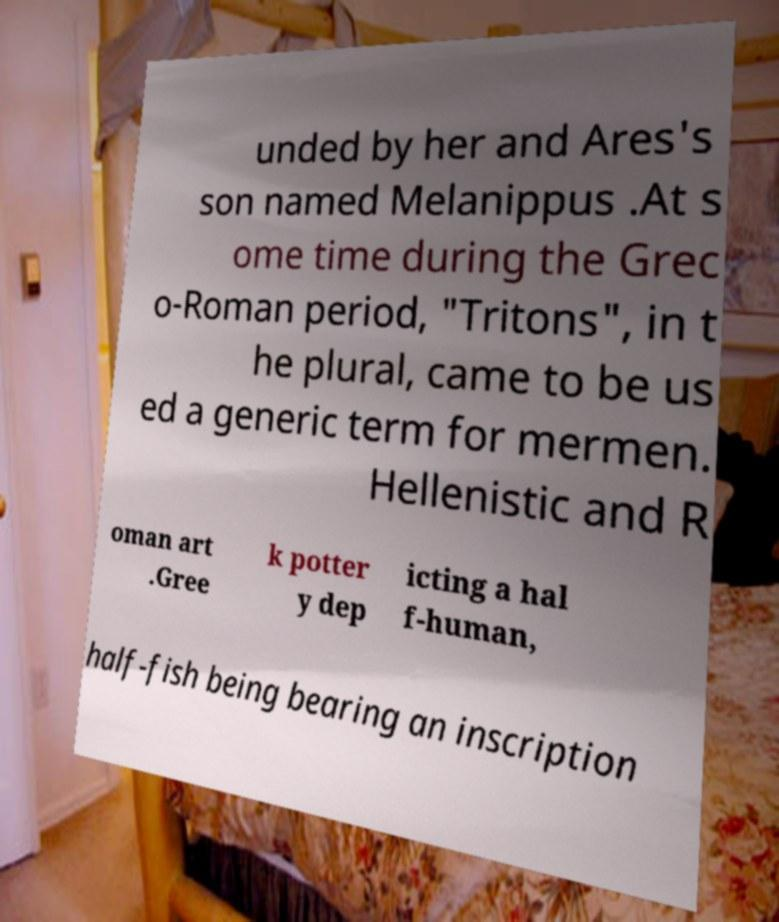Could you assist in decoding the text presented in this image and type it out clearly? unded by her and Ares's son named Melanippus .At s ome time during the Grec o-Roman period, "Tritons", in t he plural, came to be us ed a generic term for mermen. Hellenistic and R oman art .Gree k potter y dep icting a hal f-human, half-fish being bearing an inscription 